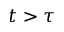Convert formula to latex. <formula><loc_0><loc_0><loc_500><loc_500>t > \tau</formula> 